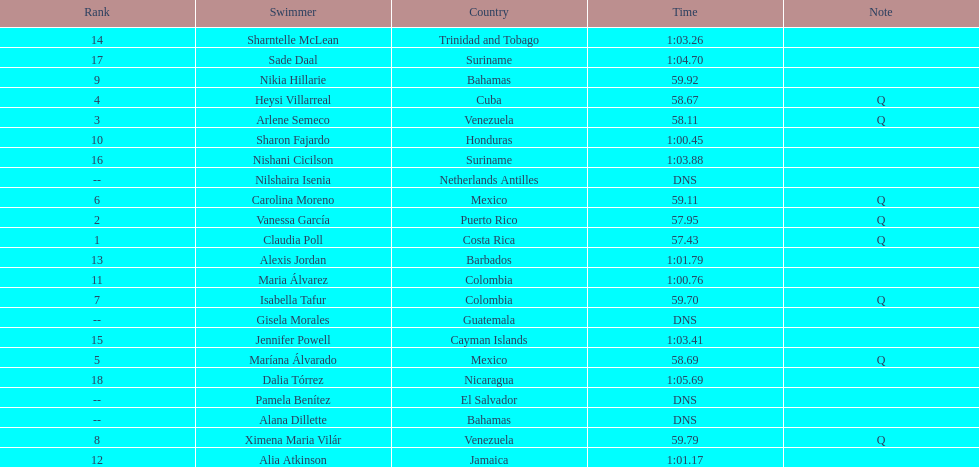How many competitors from venezuela qualified for the final? 2. 